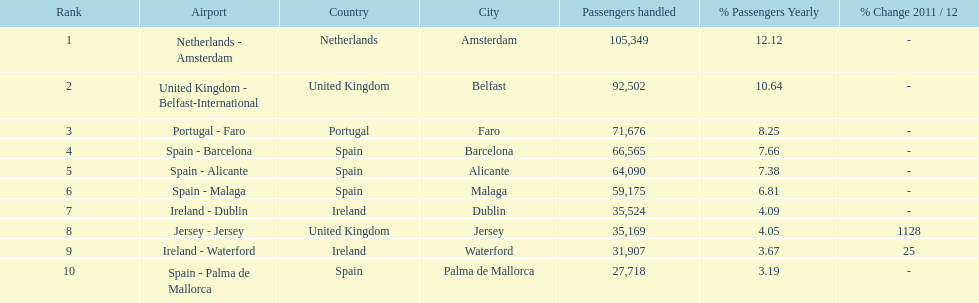Looking at the top 10 busiest routes to and from london southend airport what is the average number of passengers handled? 58,967.5. 